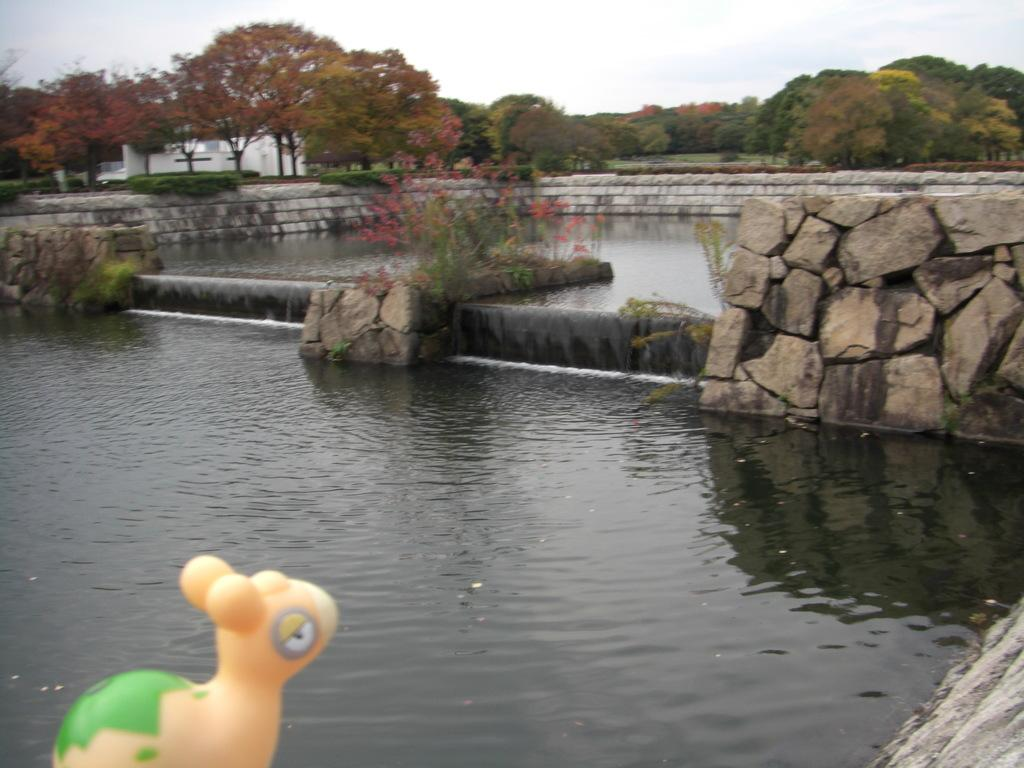What body of water is present in the image? There is a pond in the image. What type of vegetation can be seen in the background of the image? There are trees in the background of the image. What part of the natural environment is visible in the image? The sky is visible in the background of the image. Where is the toy located in the image? The toy is in the bottom left of the image. What language is being spoken by the pencil in the image? There is no pencil present in the image, and therefore no language being spoken. 